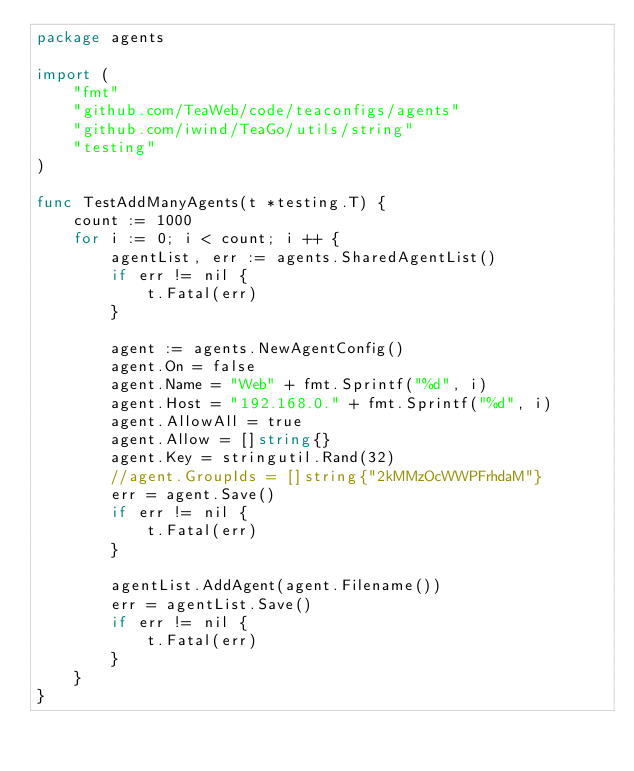Convert code to text. <code><loc_0><loc_0><loc_500><loc_500><_Go_>package agents

import (
	"fmt"
	"github.com/TeaWeb/code/teaconfigs/agents"
	"github.com/iwind/TeaGo/utils/string"
	"testing"
)

func TestAddManyAgents(t *testing.T) {
	count := 1000
	for i := 0; i < count; i ++ {
		agentList, err := agents.SharedAgentList()
		if err != nil {
			t.Fatal(err)
		}

		agent := agents.NewAgentConfig()
		agent.On = false
		agent.Name = "Web" + fmt.Sprintf("%d", i)
		agent.Host = "192.168.0." + fmt.Sprintf("%d", i)
		agent.AllowAll = true
		agent.Allow = []string{}
		agent.Key = stringutil.Rand(32)
		//agent.GroupIds = []string{"2kMMzOcWWPFrhdaM"}
		err = agent.Save()
		if err != nil {
			t.Fatal(err)
		}

		agentList.AddAgent(agent.Filename())
		err = agentList.Save()
		if err != nil {
			t.Fatal(err)
		}
	}
}
</code> 